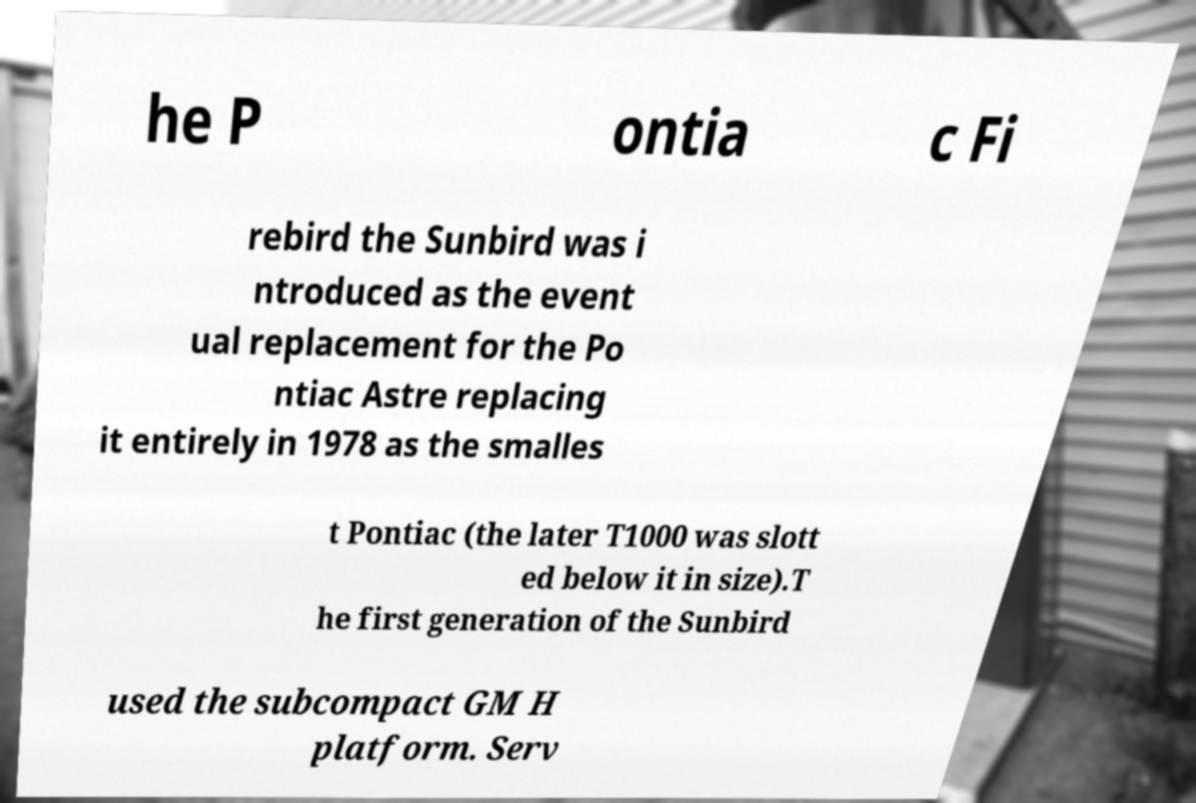Please read and relay the text visible in this image. What does it say? he P ontia c Fi rebird the Sunbird was i ntroduced as the event ual replacement for the Po ntiac Astre replacing it entirely in 1978 as the smalles t Pontiac (the later T1000 was slott ed below it in size).T he first generation of the Sunbird used the subcompact GM H platform. Serv 